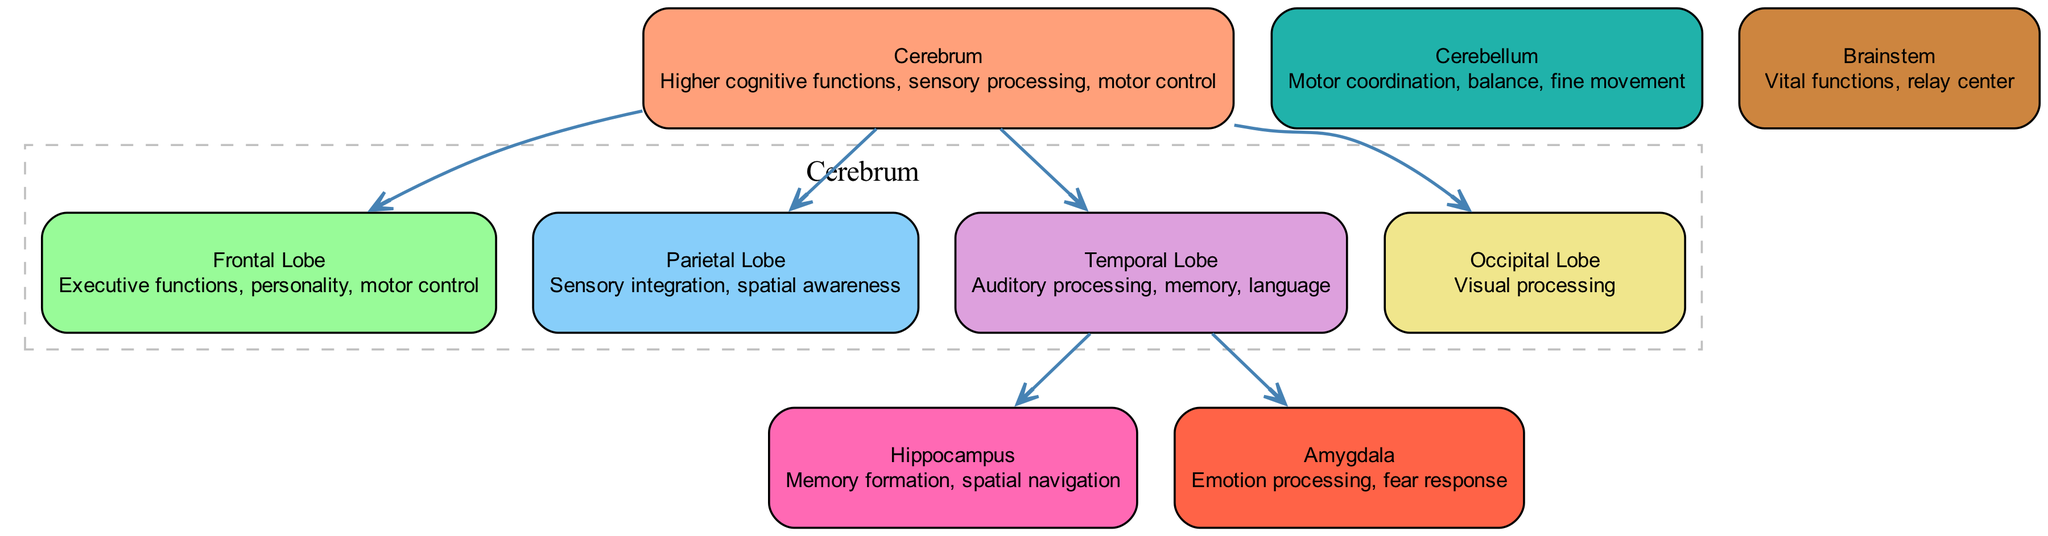What region of the brain is responsible for executive functions? The diagram shows that the Frontal Lobe is labeled with the description "Executive functions, personality, motor control." Therefore, executive functions are primarily associated with the Frontal Lobe.
Answer: Frontal Lobe How many major regions are included in the diagram? By counting the nodes listed in the data, there are a total of 9 major regions represented in the diagram, which are the Cerebrum, Frontal Lobe, Parietal Lobe, Temporal Lobe, Occipital Lobe, Cerebellum, Brainstem, Hippocampus, and Amygdala.
Answer: 9 Which lobe is primarily involved in visual processing? According to the description for the Occipital Lobe, it states "Visual processing," indicating that this lobe is primarily responsible for visual functions.
Answer: Occipital Lobe What two structures are connected to the Temporal Lobe? The diagram indicates that the Temporal Lobe has edges leading to the Hippocampus and the Amygdala. Therefore, these two structures are specifically connected to the Temporal Lobe.
Answer: Hippocampus and Amygdala What is the main function of the Cerebellum? The diagram describes the Cerebellum as responsible for "Motor coordination, balance, fine movement." Thus, the main function of the Cerebellum is to coordinate movement and maintain balance.
Answer: Motor coordination, balance, fine movement Which part of the brain serves as a relay center? The Brainstem is indicated as the structure serving vital functions and acting as a relay center within the diagram.
Answer: Brainstem How many lobes are directly associated with the Cerebrum? The edges originating from the Cerebrum connect it to four lobes: Frontal Lobe, Parietal Lobe, Temporal Lobe, and Occipital Lobe, resulting in a total of four lobes.
Answer: 4 Which brain region is specifically linked to emotion processing? The diagram explicitly shows that the Amygdala is described as responsible for "Emotion processing, fear response," directly indicating that it is linked to emotional functions.
Answer: Amygdala What is the primary function of the Hippocampus as depicted in the diagram? The diagram indicates that the Hippocampus is responsible for "Memory formation, spatial navigation," highlighting its primary function related to memory and navigation.
Answer: Memory formation, spatial navigation 